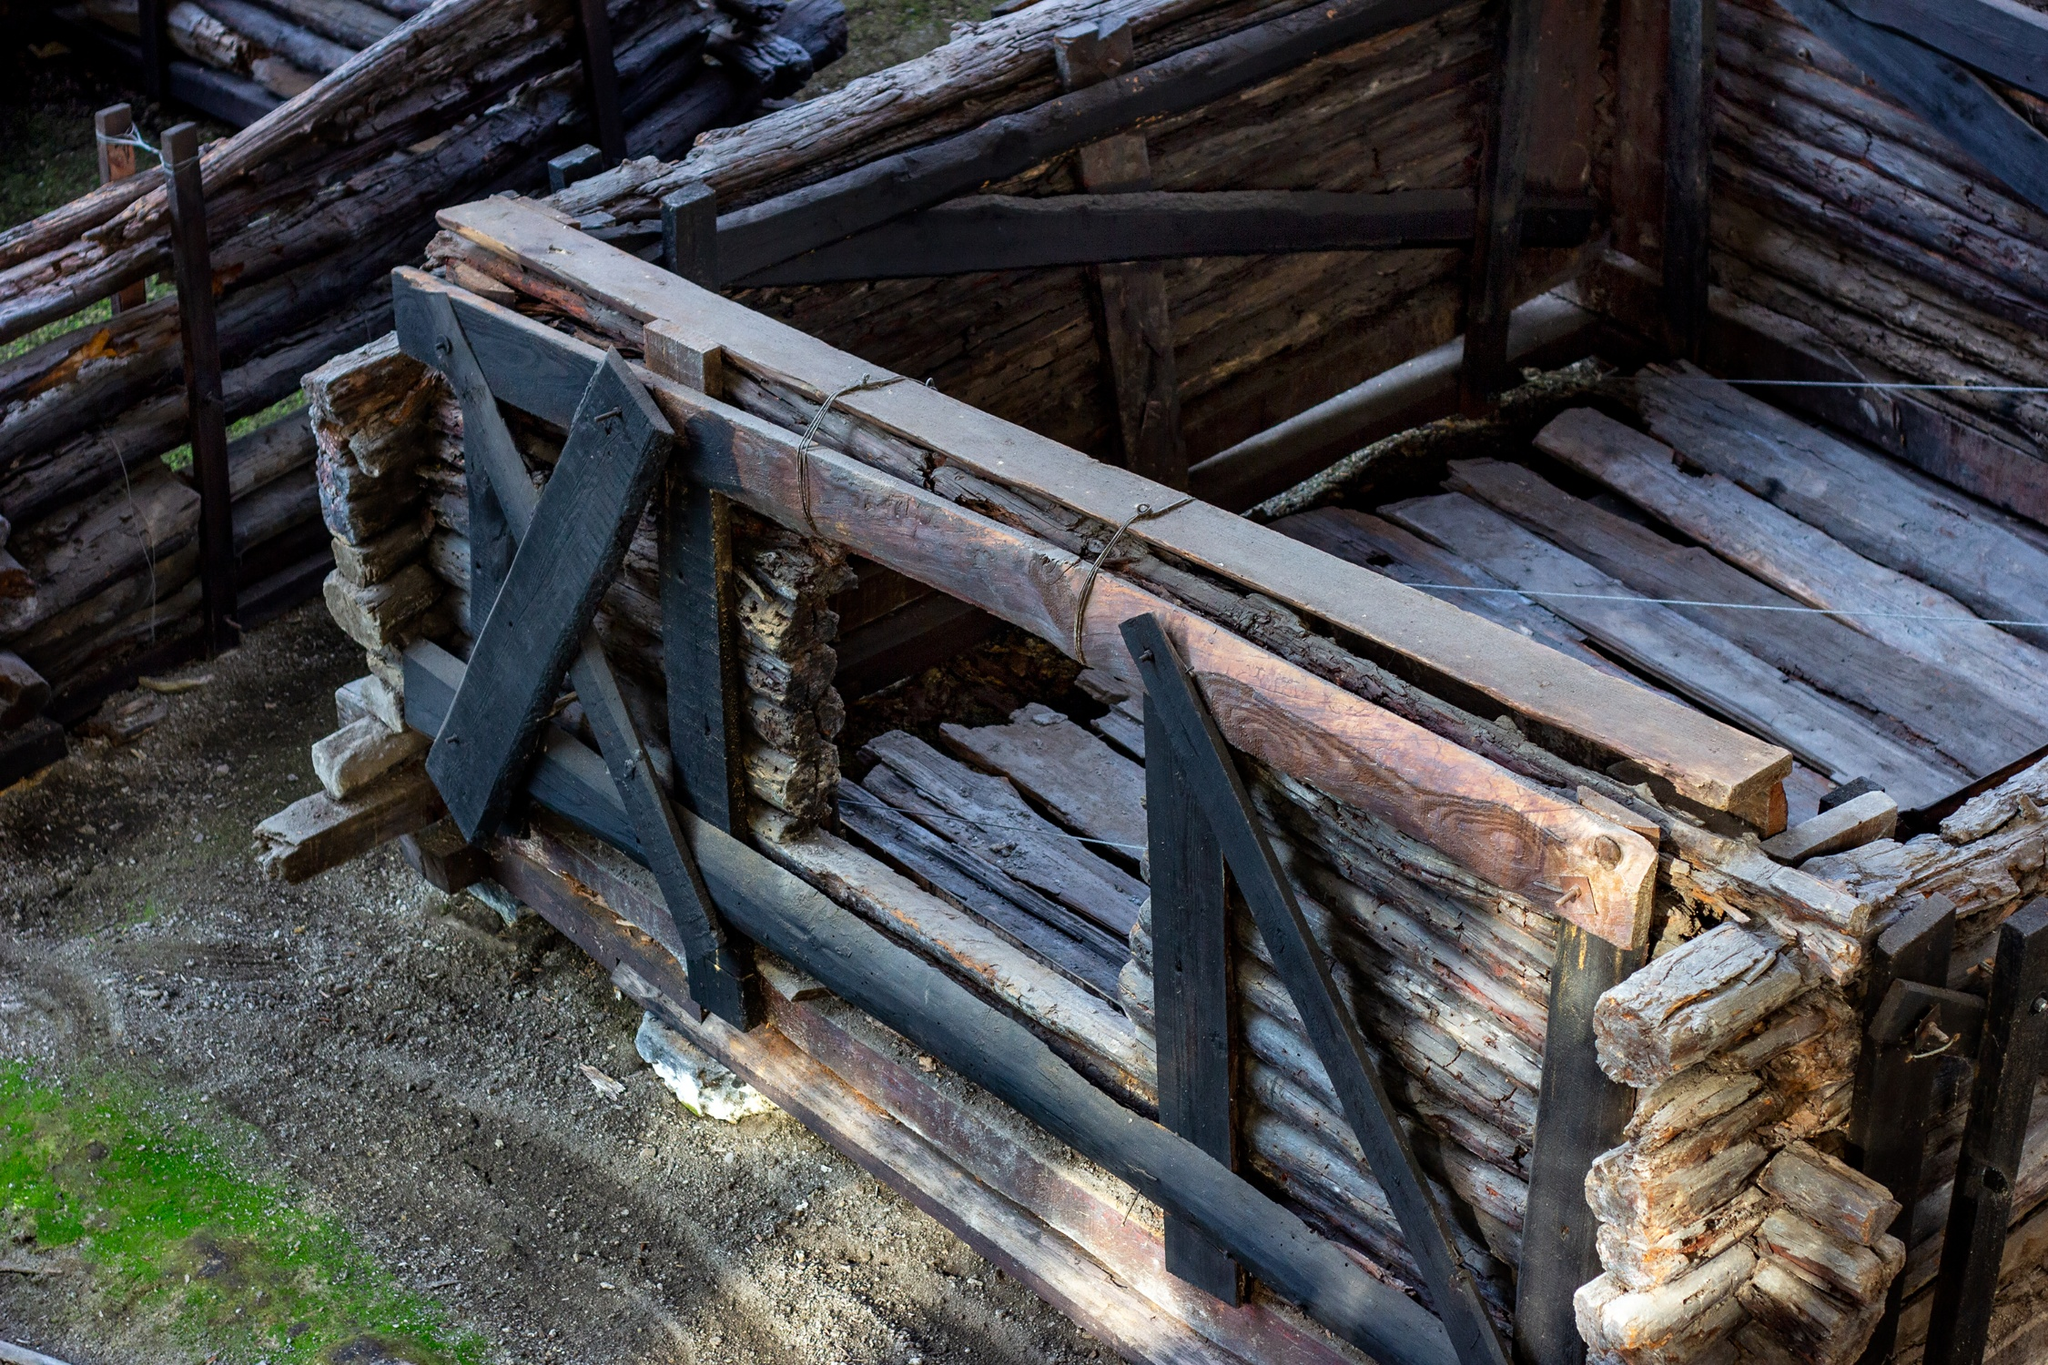Describe the following image.
 The image captures a serene scene in a forest, dominated by a rustic wooden bridge that crosses a small stream. The bridge, constructed from weathered logs, exhibits a charming patina of moss, hinting at its age and the dampness of the environment. A triangular support on one side of the bridge adds an interesting geometric contrast to the otherwise organic surroundings.

The bridge, serving as the main subject, is surrounded by a lush array of trees, their leaves forming a verdant canopy that filters the sunlight. The perspective of the image is from above and slightly to the side of the bridge, providing a comprehensive view of the bridge and the stream it spans.

The image does not provide any specific details that could be used to identify the landmark as 'sa_17441'. However, the tranquility and natural beauty of the scene are universally appealing, regardless of the specific location. The image is a testament to the harmonious coexistence of man-made structures and nature. 